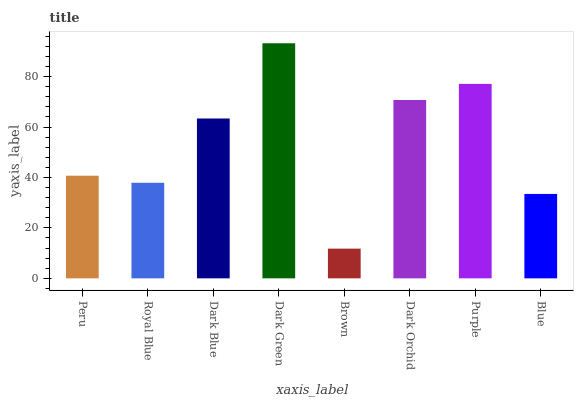Is Brown the minimum?
Answer yes or no. Yes. Is Dark Green the maximum?
Answer yes or no. Yes. Is Royal Blue the minimum?
Answer yes or no. No. Is Royal Blue the maximum?
Answer yes or no. No. Is Peru greater than Royal Blue?
Answer yes or no. Yes. Is Royal Blue less than Peru?
Answer yes or no. Yes. Is Royal Blue greater than Peru?
Answer yes or no. No. Is Peru less than Royal Blue?
Answer yes or no. No. Is Dark Blue the high median?
Answer yes or no. Yes. Is Peru the low median?
Answer yes or no. Yes. Is Peru the high median?
Answer yes or no. No. Is Brown the low median?
Answer yes or no. No. 